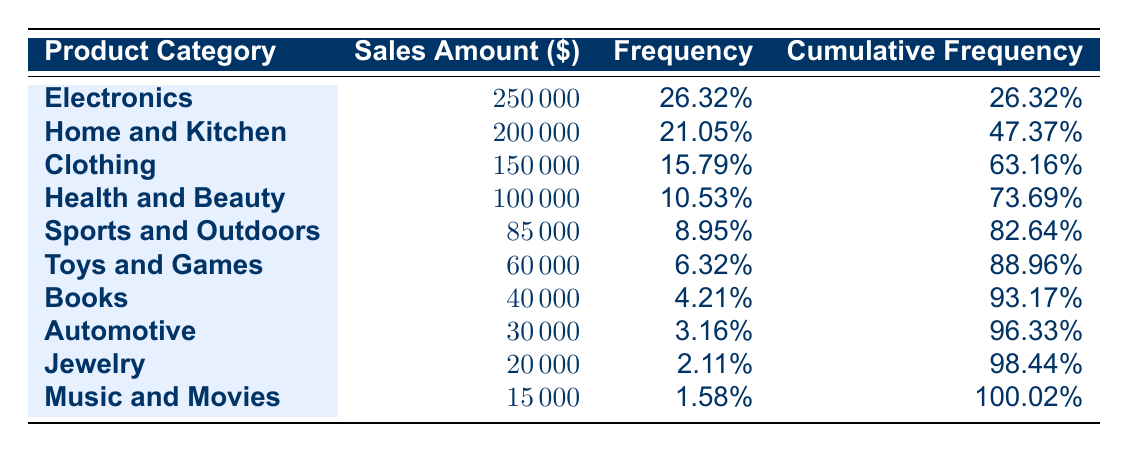What is the product category with the highest sales amount? The highest sales amount is found in the row for Electronics, which has a sales amount of 250,000.
Answer: Electronics What is the sales amount for Health and Beauty? Referring to the table, the sales amount listed for Health and Beauty is 100,000.
Answer: 100000 Which product category had a sales amount less than 100,000? By examining the sales amounts, both Toys and Games (60,000) and Jewelry (20,000) fall below 100,000.
Answer: Toys and Games, Jewelry What is the total sales amount for the top three product categories? The top three product categories are Electronics (250,000), Home and Kitchen (200,000), and Clothing (150,000). Adding these amounts: 250,000 + 200,000 + 150,000 = 600,000.
Answer: 600000 Is the sales amount for Automotive greater than that of Music and Movies? The sales amount for Automotive is 30,000 and for Music and Movies it is 15,000. Since 30,000 is greater than 15,000, the statement is true.
Answer: Yes What is the cumulative frequency for the Clothing category? The cumulative frequency for Clothing is 63.16%. This is derived by adding the frequency of Electronics (26.32%), Home and Kitchen (21.05%), and Clothing itself (15.79%), giving a total of 63.16%.
Answer: 63.16% Calculate the average sales amount for product categories with sales over 70,000. The categories with sales over 70,000 are Electronics (250,000), Home and Kitchen (200,000), and Clothing (150,000). The total for these categories is 600,000. There are three categories, so the average is 600,000 / 3 = 200,000.
Answer: 200000 How many product categories have a sales amount of 50,000 or more? The categories with sales amounts of 50,000 or more are Electronics, Home and Kitchen, Clothing, Health and Beauty, Sports and Outdoors, and Toys and Games. This totals six categories.
Answer: 6 Does Jewelry have the highest frequency percentage compared to other product categories? Jewelry has a frequency of 2.11%, which is less than that of other categories like Electronics (26.32%), Home and Kitchen (21.05%), and Clothing (15.79%), therefore it does not have the highest frequency percentage.
Answer: No 